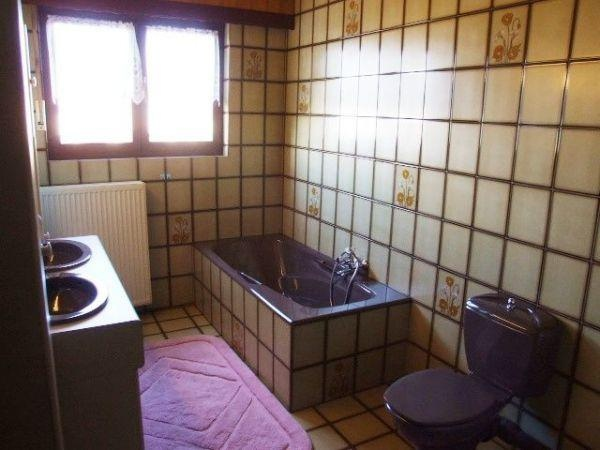Describe the objects in this image and their specific colors. I can see toilet in black tones, sink in black, navy, maroon, and purple tones, and sink in black and gray tones in this image. 